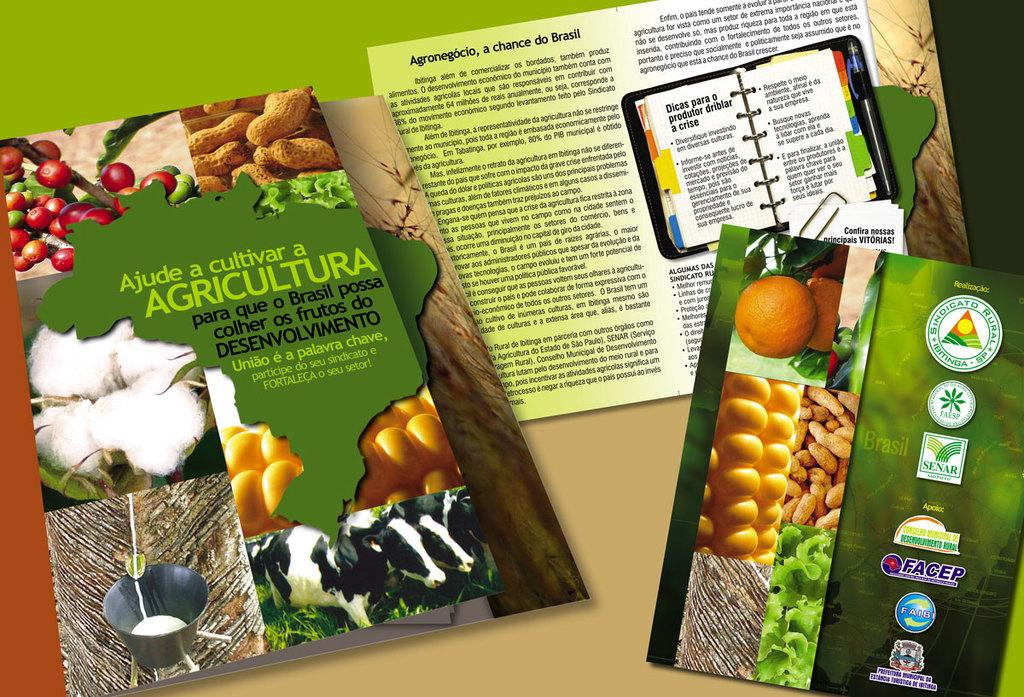What type of objects can be seen on the book covers in the image? The book covers have images of a bucket, cows, eggs, oranges, and peanuts. Can you describe the variety of objects depicted on the book covers? The objects depicted on the book covers include a bucket, cows, eggs, oranges, and peanuts. What type of powder can be seen on the book covers in the image? There is no powder present on the book covers in the image. What type of coal is depicted on the book covers in the image? There is no coal depicted on the book covers in the image. 